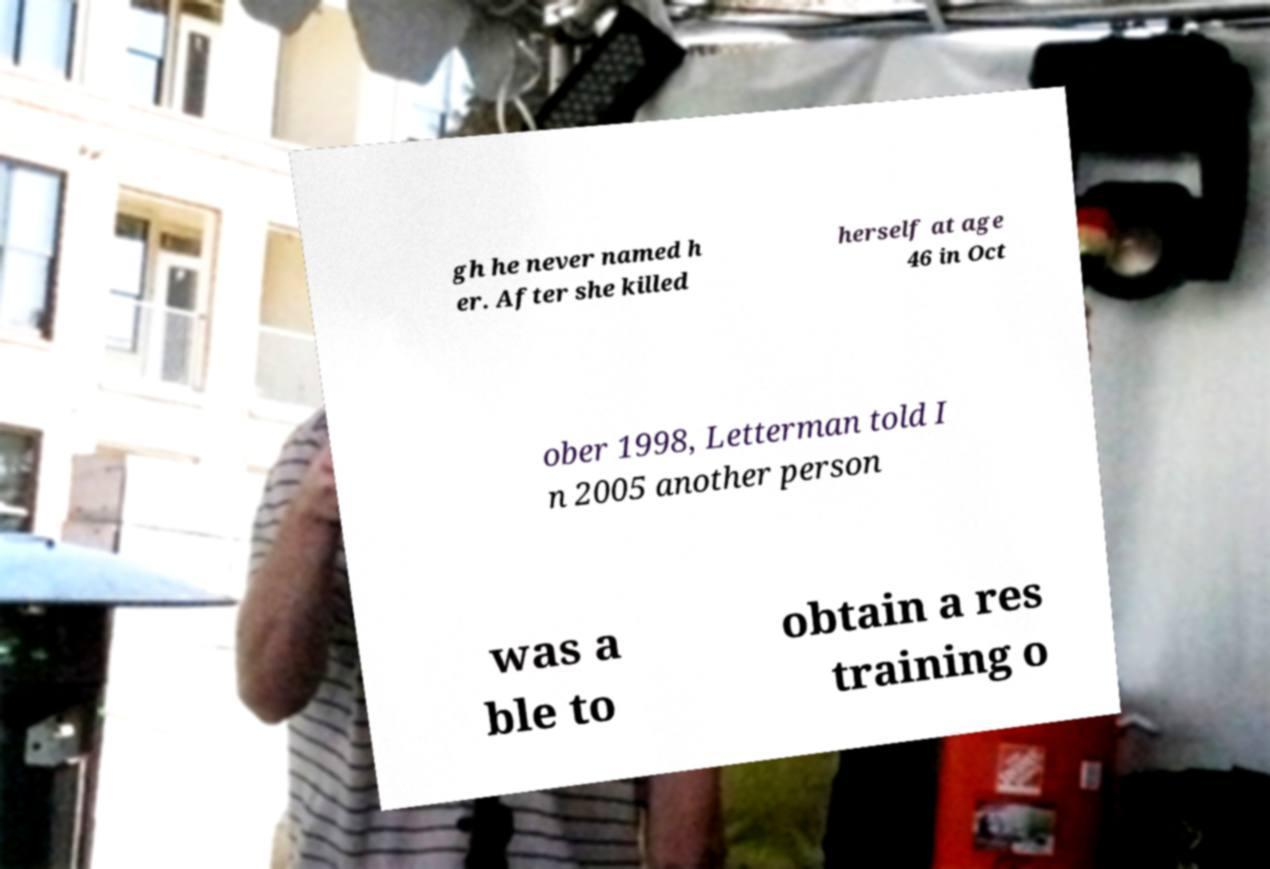Could you assist in decoding the text presented in this image and type it out clearly? gh he never named h er. After she killed herself at age 46 in Oct ober 1998, Letterman told I n 2005 another person was a ble to obtain a res training o 